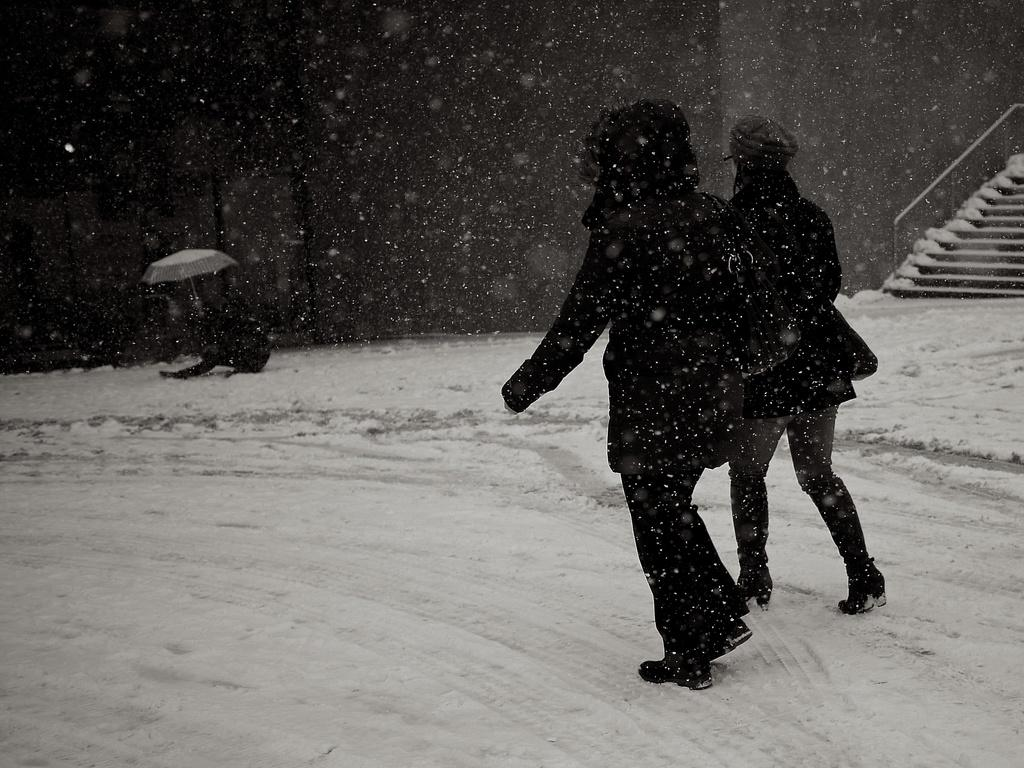What are the people in the image doing? People are walking in the snow. What object can be seen in the image that might provide protection from the snow? There is an umbrella in the image. What architectural feature is visible in the image? There are stairs in the image. What type of watch is the creator wearing in the image? There is no creator or watch present in the image. Is there a baseball game happening in the image? There is no baseball game or related equipment visible in the image. 